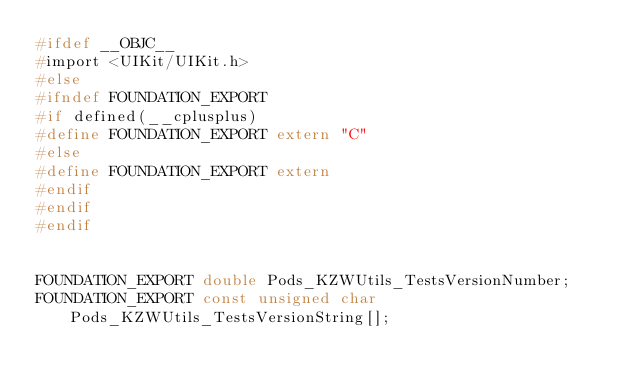<code> <loc_0><loc_0><loc_500><loc_500><_C_>#ifdef __OBJC__
#import <UIKit/UIKit.h>
#else
#ifndef FOUNDATION_EXPORT
#if defined(__cplusplus)
#define FOUNDATION_EXPORT extern "C"
#else
#define FOUNDATION_EXPORT extern
#endif
#endif
#endif


FOUNDATION_EXPORT double Pods_KZWUtils_TestsVersionNumber;
FOUNDATION_EXPORT const unsigned char Pods_KZWUtils_TestsVersionString[];

</code> 